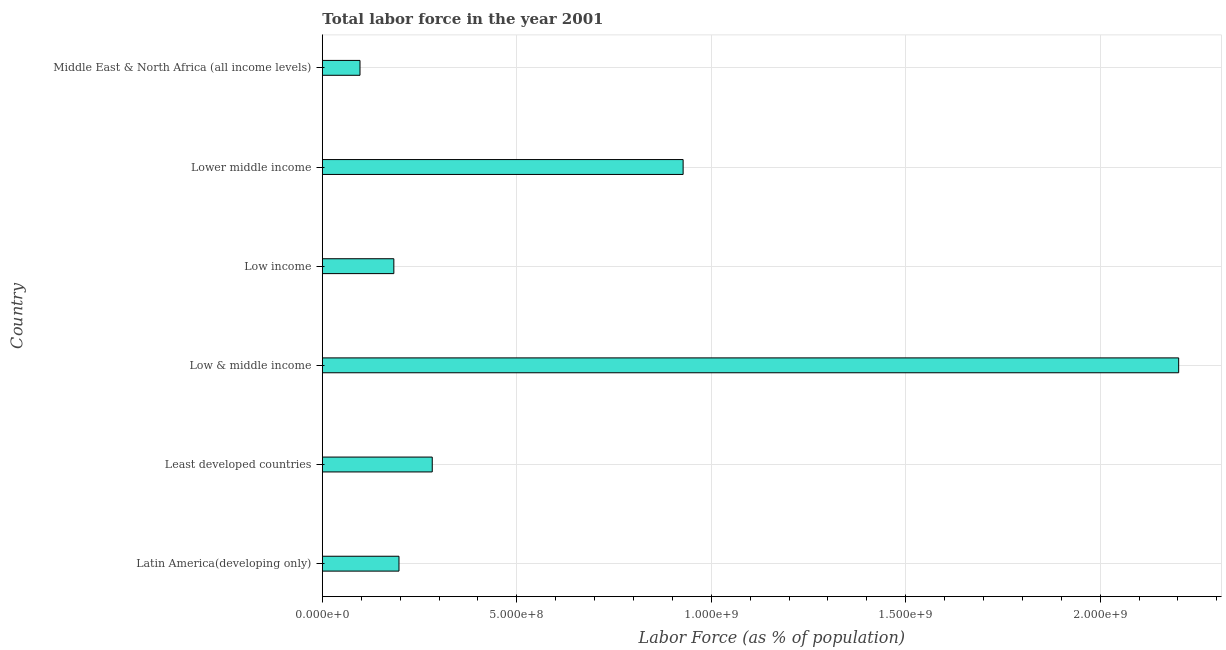Does the graph contain any zero values?
Provide a short and direct response. No. What is the title of the graph?
Offer a very short reply. Total labor force in the year 2001. What is the label or title of the X-axis?
Your answer should be compact. Labor Force (as % of population). What is the label or title of the Y-axis?
Offer a terse response. Country. What is the total labor force in Low & middle income?
Offer a terse response. 2.20e+09. Across all countries, what is the maximum total labor force?
Your answer should be compact. 2.20e+09. Across all countries, what is the minimum total labor force?
Your answer should be very brief. 9.69e+07. In which country was the total labor force minimum?
Your response must be concise. Middle East & North Africa (all income levels). What is the sum of the total labor force?
Your answer should be very brief. 3.89e+09. What is the difference between the total labor force in Lower middle income and Middle East & North Africa (all income levels)?
Your answer should be compact. 8.31e+08. What is the average total labor force per country?
Provide a short and direct response. 6.48e+08. What is the median total labor force?
Keep it short and to the point. 2.40e+08. In how many countries, is the total labor force greater than 2200000000 %?
Your answer should be very brief. 1. What is the ratio of the total labor force in Least developed countries to that in Middle East & North Africa (all income levels)?
Give a very brief answer. 2.92. What is the difference between the highest and the second highest total labor force?
Provide a short and direct response. 1.27e+09. Is the sum of the total labor force in Latin America(developing only) and Low income greater than the maximum total labor force across all countries?
Keep it short and to the point. No. What is the difference between the highest and the lowest total labor force?
Keep it short and to the point. 2.11e+09. Are all the bars in the graph horizontal?
Provide a succinct answer. Yes. Are the values on the major ticks of X-axis written in scientific E-notation?
Give a very brief answer. Yes. What is the Labor Force (as % of population) in Latin America(developing only)?
Provide a short and direct response. 1.97e+08. What is the Labor Force (as % of population) of Least developed countries?
Offer a very short reply. 2.83e+08. What is the Labor Force (as % of population) in Low & middle income?
Provide a succinct answer. 2.20e+09. What is the Labor Force (as % of population) of Low income?
Keep it short and to the point. 1.84e+08. What is the Labor Force (as % of population) in Lower middle income?
Keep it short and to the point. 9.28e+08. What is the Labor Force (as % of population) of Middle East & North Africa (all income levels)?
Provide a succinct answer. 9.69e+07. What is the difference between the Labor Force (as % of population) in Latin America(developing only) and Least developed countries?
Your response must be concise. -8.55e+07. What is the difference between the Labor Force (as % of population) in Latin America(developing only) and Low & middle income?
Provide a short and direct response. -2.00e+09. What is the difference between the Labor Force (as % of population) in Latin America(developing only) and Low income?
Keep it short and to the point. 1.32e+07. What is the difference between the Labor Force (as % of population) in Latin America(developing only) and Lower middle income?
Your response must be concise. -7.31e+08. What is the difference between the Labor Force (as % of population) in Latin America(developing only) and Middle East & North Africa (all income levels)?
Provide a short and direct response. 1.00e+08. What is the difference between the Labor Force (as % of population) in Least developed countries and Low & middle income?
Provide a short and direct response. -1.92e+09. What is the difference between the Labor Force (as % of population) in Least developed countries and Low income?
Your answer should be compact. 9.87e+07. What is the difference between the Labor Force (as % of population) in Least developed countries and Lower middle income?
Your answer should be very brief. -6.45e+08. What is the difference between the Labor Force (as % of population) in Least developed countries and Middle East & North Africa (all income levels)?
Ensure brevity in your answer.  1.86e+08. What is the difference between the Labor Force (as % of population) in Low & middle income and Low income?
Give a very brief answer. 2.02e+09. What is the difference between the Labor Force (as % of population) in Low & middle income and Lower middle income?
Your answer should be very brief. 1.27e+09. What is the difference between the Labor Force (as % of population) in Low & middle income and Middle East & North Africa (all income levels)?
Keep it short and to the point. 2.11e+09. What is the difference between the Labor Force (as % of population) in Low income and Lower middle income?
Offer a very short reply. -7.44e+08. What is the difference between the Labor Force (as % of population) in Low income and Middle East & North Africa (all income levels)?
Provide a short and direct response. 8.70e+07. What is the difference between the Labor Force (as % of population) in Lower middle income and Middle East & North Africa (all income levels)?
Your answer should be compact. 8.31e+08. What is the ratio of the Labor Force (as % of population) in Latin America(developing only) to that in Least developed countries?
Make the answer very short. 0.7. What is the ratio of the Labor Force (as % of population) in Latin America(developing only) to that in Low & middle income?
Your response must be concise. 0.09. What is the ratio of the Labor Force (as % of population) in Latin America(developing only) to that in Low income?
Keep it short and to the point. 1.07. What is the ratio of the Labor Force (as % of population) in Latin America(developing only) to that in Lower middle income?
Offer a terse response. 0.21. What is the ratio of the Labor Force (as % of population) in Latin America(developing only) to that in Middle East & North Africa (all income levels)?
Offer a terse response. 2.04. What is the ratio of the Labor Force (as % of population) in Least developed countries to that in Low & middle income?
Offer a very short reply. 0.13. What is the ratio of the Labor Force (as % of population) in Least developed countries to that in Low income?
Provide a short and direct response. 1.54. What is the ratio of the Labor Force (as % of population) in Least developed countries to that in Lower middle income?
Your response must be concise. 0.3. What is the ratio of the Labor Force (as % of population) in Least developed countries to that in Middle East & North Africa (all income levels)?
Provide a short and direct response. 2.92. What is the ratio of the Labor Force (as % of population) in Low & middle income to that in Low income?
Provide a short and direct response. 11.97. What is the ratio of the Labor Force (as % of population) in Low & middle income to that in Lower middle income?
Offer a terse response. 2.37. What is the ratio of the Labor Force (as % of population) in Low & middle income to that in Middle East & North Africa (all income levels)?
Provide a short and direct response. 22.73. What is the ratio of the Labor Force (as % of population) in Low income to that in Lower middle income?
Offer a very short reply. 0.2. What is the ratio of the Labor Force (as % of population) in Low income to that in Middle East & North Africa (all income levels)?
Your answer should be compact. 1.9. What is the ratio of the Labor Force (as % of population) in Lower middle income to that in Middle East & North Africa (all income levels)?
Ensure brevity in your answer.  9.58. 